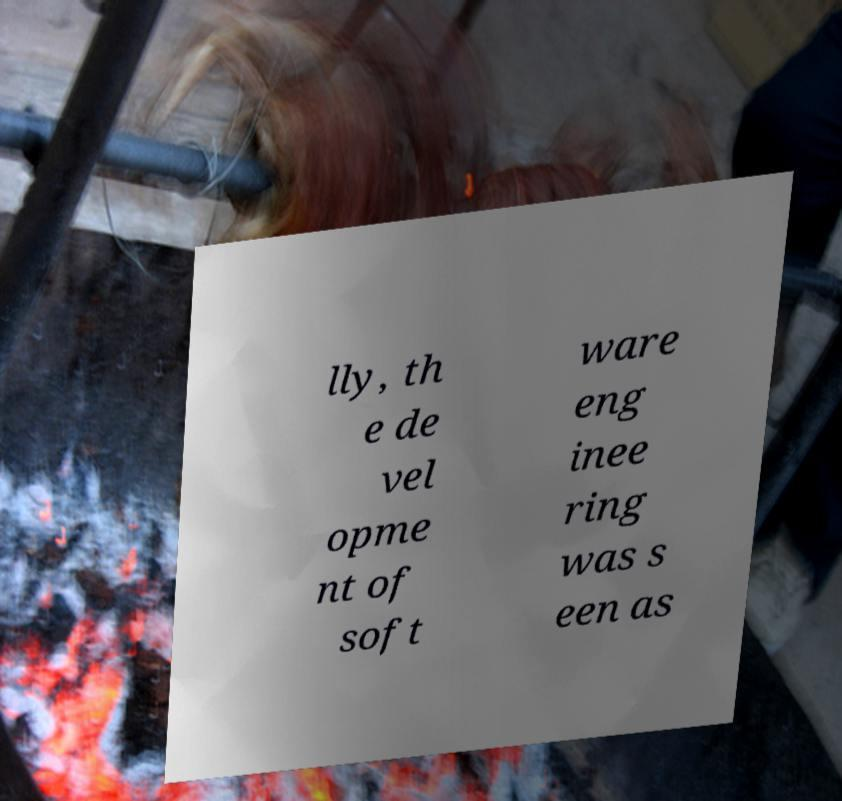There's text embedded in this image that I need extracted. Can you transcribe it verbatim? lly, th e de vel opme nt of soft ware eng inee ring was s een as 